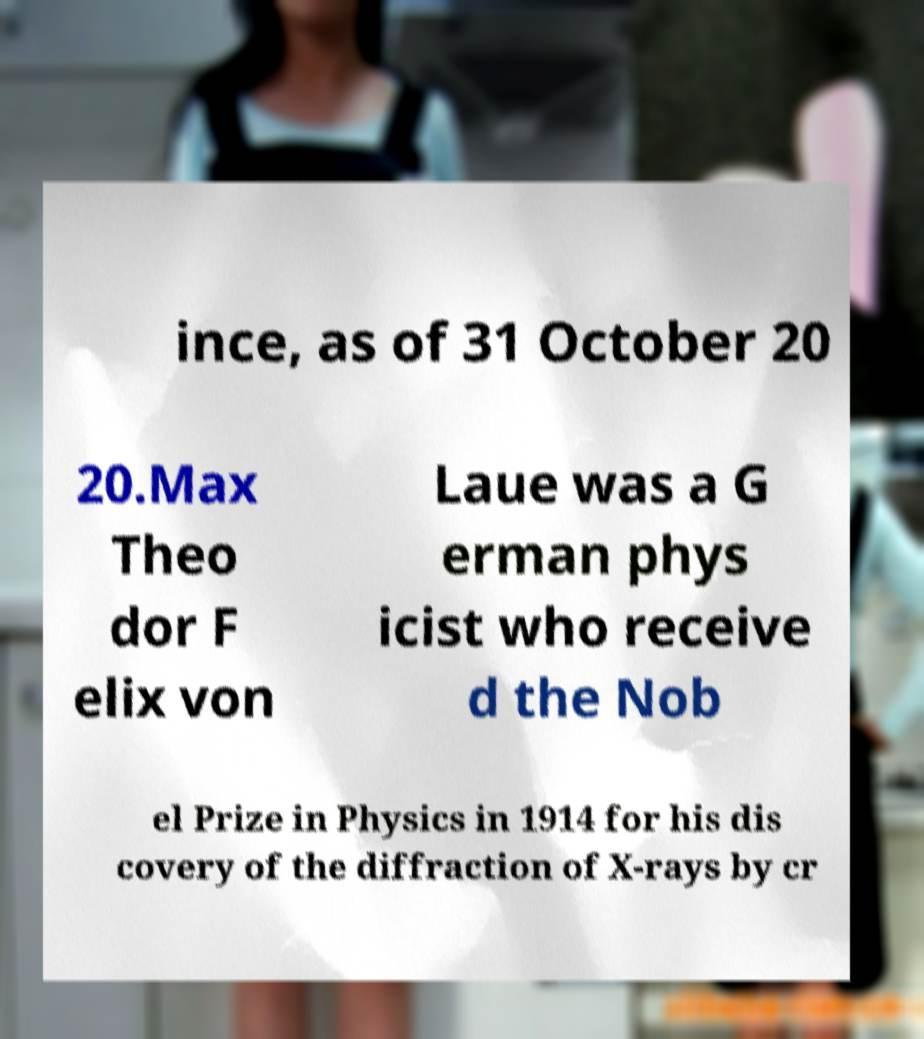I need the written content from this picture converted into text. Can you do that? ince, as of 31 October 20 20.Max Theo dor F elix von Laue was a G erman phys icist who receive d the Nob el Prize in Physics in 1914 for his dis covery of the diffraction of X-rays by cr 